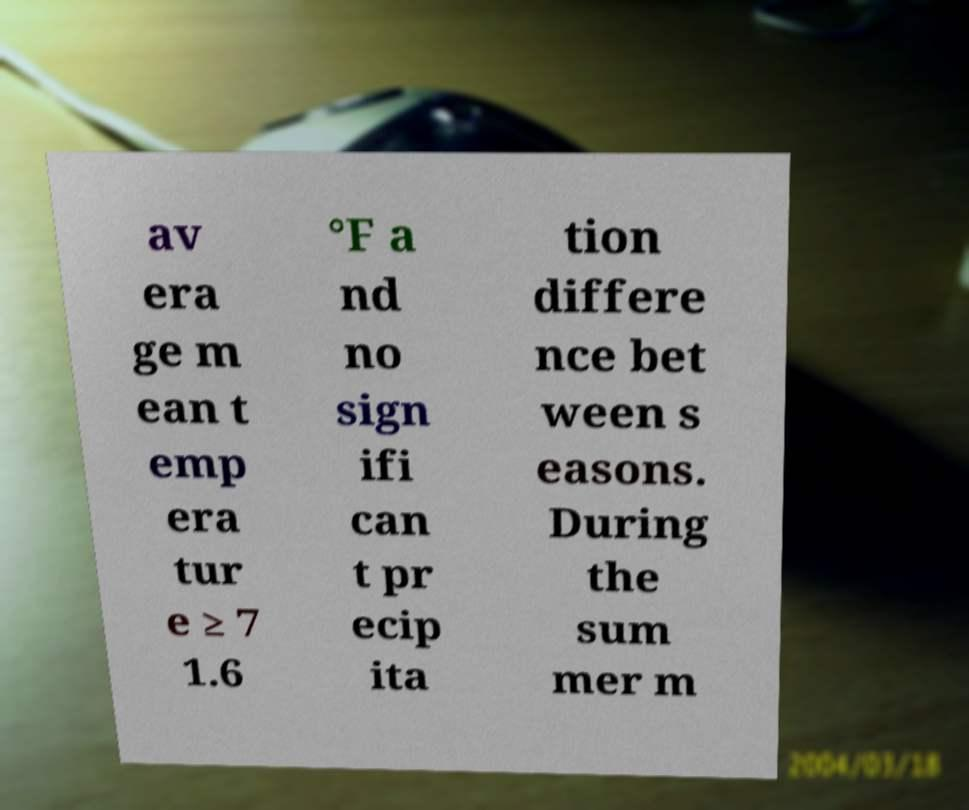I need the written content from this picture converted into text. Can you do that? av era ge m ean t emp era tur e ≥ 7 1.6 °F a nd no sign ifi can t pr ecip ita tion differe nce bet ween s easons. During the sum mer m 